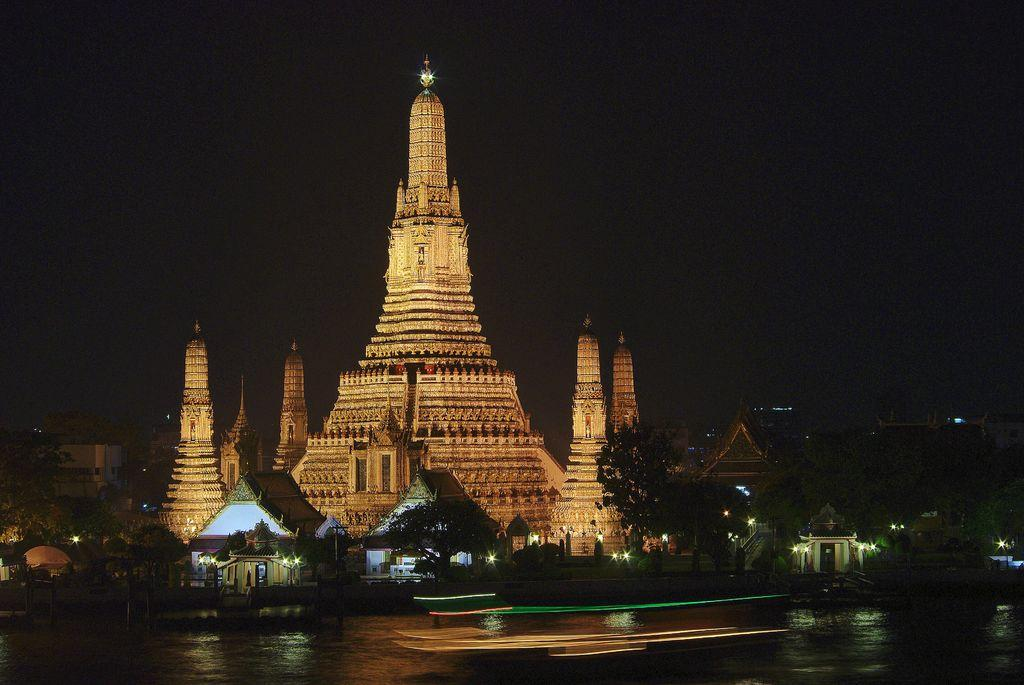What type of structure is visible in the image? There is a building in the image. What natural element is present in the image? There is water in the image. What type of vegetation is near the water? Trees are present on the sides of the water. Are there any other structures near the water? Yes, there are small buildings on the sides of the water. How would you describe the lighting in the image? The background of the image is dark. What type of toothpaste is being used to paint the small buildings in the image? There is no toothpaste present in the image, and the small buildings are not being painted. 